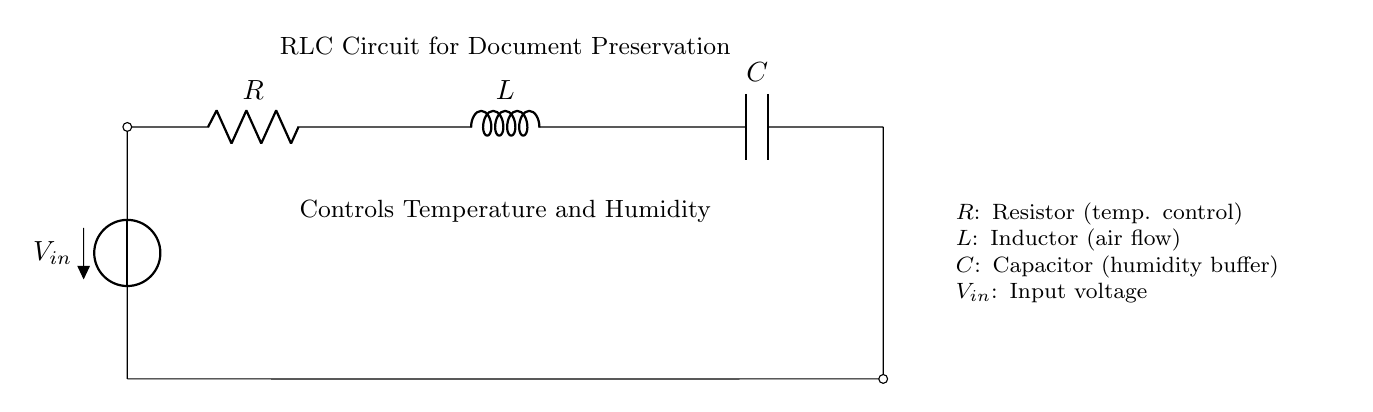What is the voltage source in this circuit? The voltage source is labeled V in the diagram, indicating the input voltage for the circuit.
Answer: V What are the components used in this RLC circuit? The schematic shows three main components: a resistor (R), an inductor (L), and a capacitor (C), which are essential for controlling temperature and humidity.
Answer: Resistor, Inductor, Capacitor How does the resistor contribute to document preservation? The resistor in this circuit helps control the temperature by managing the current flow, which can directly influence heating elements or cooling systems linked to the preservation setup.
Answer: Temperature control What is the role of the inductor in the circuit? The inductor is responsible for managing air flow within the preservation environment, as it stores energy in the magnetic field when current passes through it and releases it as needed.
Answer: Air flow What does the capacitor do in this circuit? The capacitor acts as a humidity buffer, storing electrical energy and helping to regulate moisture levels around the historical documents to prevent deterioration due to overly dry or humid conditions.
Answer: Humidity buffer What could happen if the resistor is too high in resistance? If the resistor has too high of a resistance, it could limit the current excessively, resulting in insufficient heating or cooling, which may not maintain the desired temperature for document preservation.
Answer: Insufficient control What type of circuit is this and why is it relevant for preserving delicate documents? This is a Resistor-Inductor-Capacitor (RLC) circuit, which is relevant for maintaining stable temperature and humidity levels essential for preserving delicate historical documents from degradation.
Answer: RLC circuit 